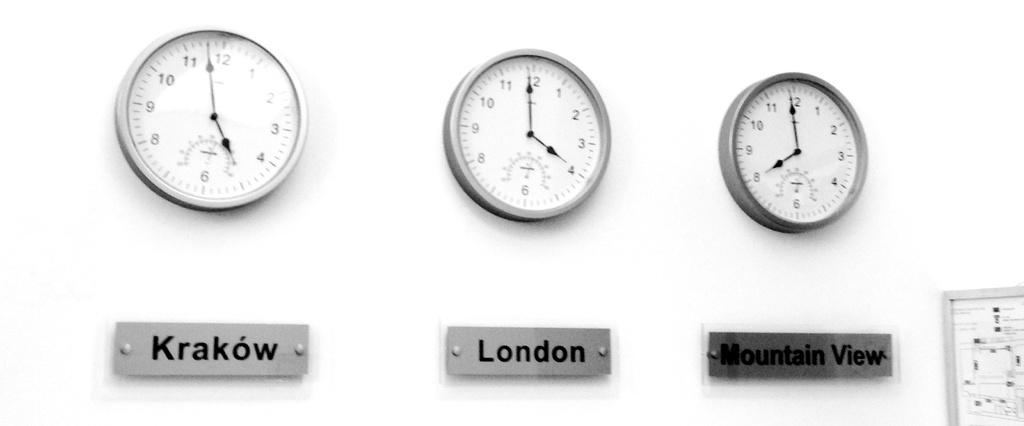What city is listed in the middle?
Give a very brief answer. London. What city is listed in our left?
Your answer should be very brief. Krakow. 